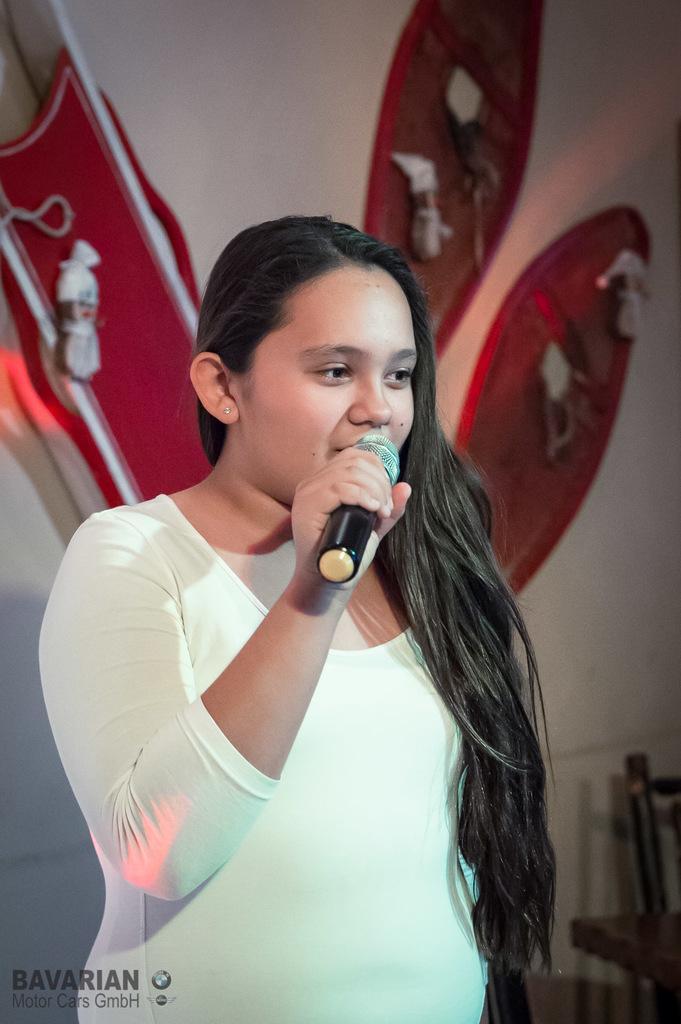How would you summarize this image in a sentence or two? There is a woman standing and singing in the center of the picture. In the background there is a design. 